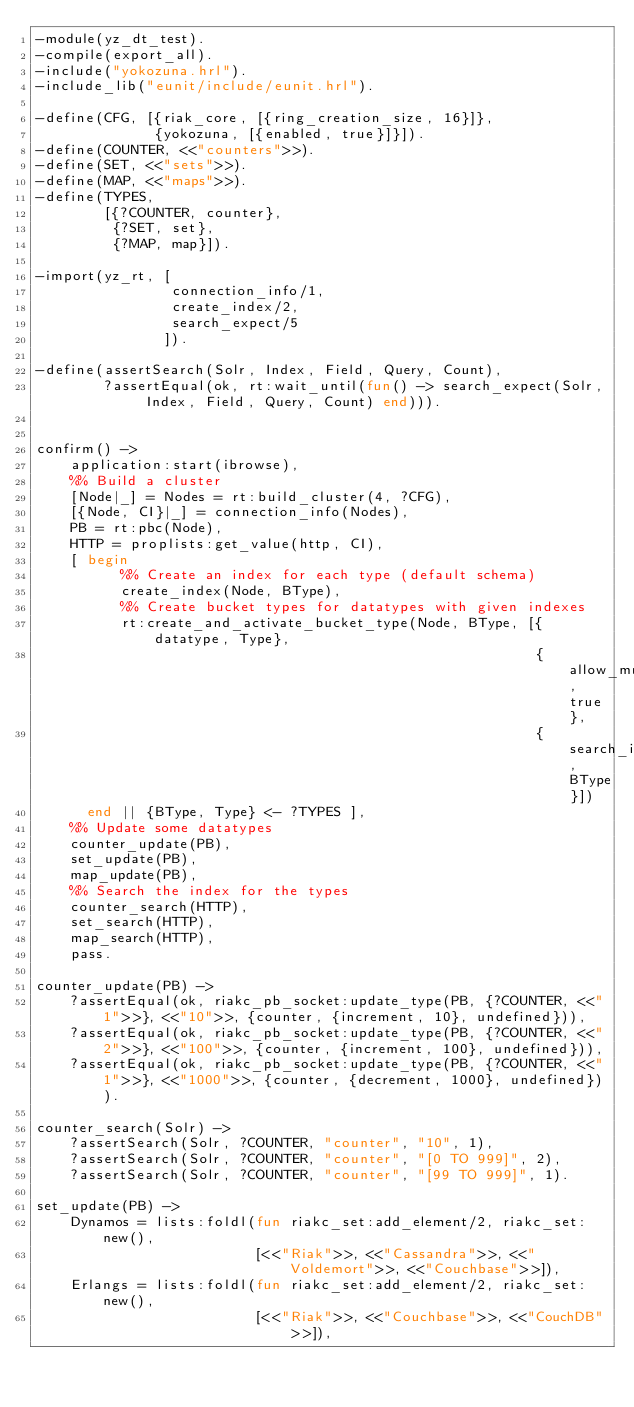Convert code to text. <code><loc_0><loc_0><loc_500><loc_500><_Erlang_>-module(yz_dt_test).
-compile(export_all).
-include("yokozuna.hrl").
-include_lib("eunit/include/eunit.hrl").

-define(CFG, [{riak_core, [{ring_creation_size, 16}]},
              {yokozuna, [{enabled, true}]}]).
-define(COUNTER, <<"counters">>).
-define(SET, <<"sets">>).
-define(MAP, <<"maps">>).
-define(TYPES,
        [{?COUNTER, counter},
         {?SET, set},
         {?MAP, map}]).

-import(yz_rt, [
                connection_info/1,
                create_index/2,
                search_expect/5
               ]).

-define(assertSearch(Solr, Index, Field, Query, Count),
        ?assertEqual(ok, rt:wait_until(fun() -> search_expect(Solr, Index, Field, Query, Count) end))).


confirm() ->
    application:start(ibrowse),
    %% Build a cluster
    [Node|_] = Nodes = rt:build_cluster(4, ?CFG),
    [{Node, CI}|_] = connection_info(Nodes),
    PB = rt:pbc(Node),
    HTTP = proplists:get_value(http, CI),
    [ begin
          %% Create an index for each type (default schema)
          create_index(Node, BType),
          %% Create bucket types for datatypes with given indexes
          rt:create_and_activate_bucket_type(Node, BType, [{datatype, Type},
                                                           {allow_mult, true},
                                                           {search_index, BType}])
      end || {BType, Type} <- ?TYPES ],
    %% Update some datatypes
    counter_update(PB),
    set_update(PB),
    map_update(PB),
    %% Search the index for the types
    counter_search(HTTP),
    set_search(HTTP),
    map_search(HTTP),
    pass.

counter_update(PB) ->
    ?assertEqual(ok, riakc_pb_socket:update_type(PB, {?COUNTER, <<"1">>}, <<"10">>, {counter, {increment, 10}, undefined})),
    ?assertEqual(ok, riakc_pb_socket:update_type(PB, {?COUNTER, <<"2">>}, <<"100">>, {counter, {increment, 100}, undefined})),
    ?assertEqual(ok, riakc_pb_socket:update_type(PB, {?COUNTER, <<"1">>}, <<"1000">>, {counter, {decrement, 1000}, undefined})).

counter_search(Solr) ->
    ?assertSearch(Solr, ?COUNTER, "counter", "10", 1),
    ?assertSearch(Solr, ?COUNTER, "counter", "[0 TO 999]", 2),
    ?assertSearch(Solr, ?COUNTER, "counter", "[99 TO 999]", 1).

set_update(PB) ->
    Dynamos = lists:foldl(fun riakc_set:add_element/2, riakc_set:new(),
                          [<<"Riak">>, <<"Cassandra">>, <<"Voldemort">>, <<"Couchbase">>]),
    Erlangs = lists:foldl(fun riakc_set:add_element/2, riakc_set:new(),
                          [<<"Riak">>, <<"Couchbase">>, <<"CouchDB">>]),</code> 